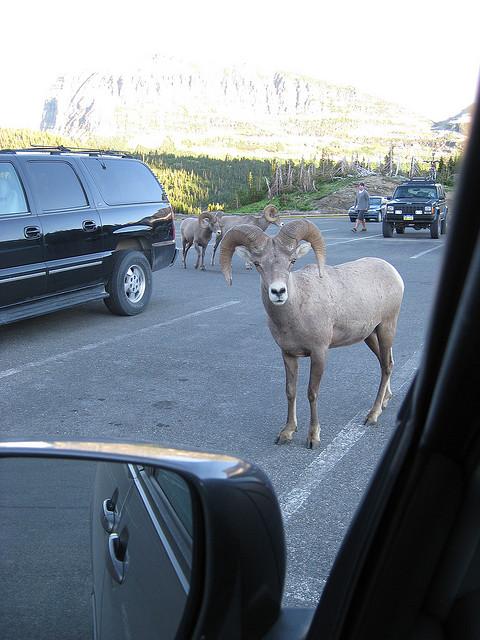Should this person get out of their car right now?
Give a very brief answer. No. What is the antelope looking at?
Be succinct. Car. Are the animals domesticated?
Answer briefly. No. What kind of animal is that?
Quick response, please. Ram. What color is the closer ram?
Short answer required. Brown. What car is behind this vehicle?
Answer briefly. Jeep. How many ram horns are there?
Give a very brief answer. 2. 